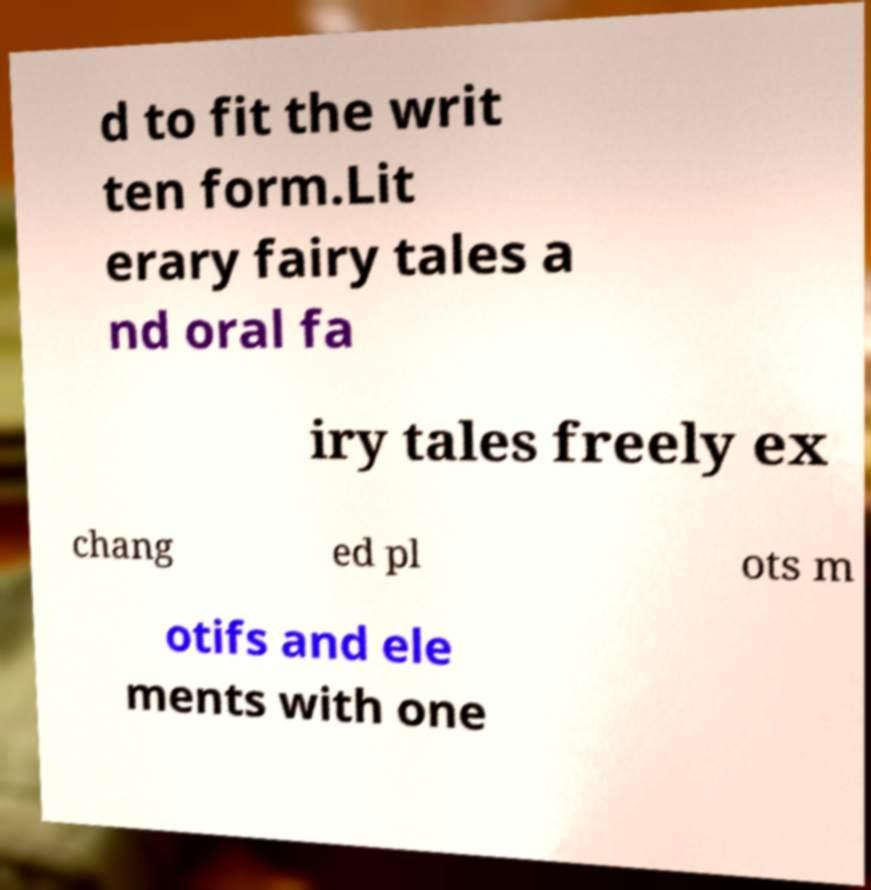Can you read and provide the text displayed in the image?This photo seems to have some interesting text. Can you extract and type it out for me? d to fit the writ ten form.Lit erary fairy tales a nd oral fa iry tales freely ex chang ed pl ots m otifs and ele ments with one 